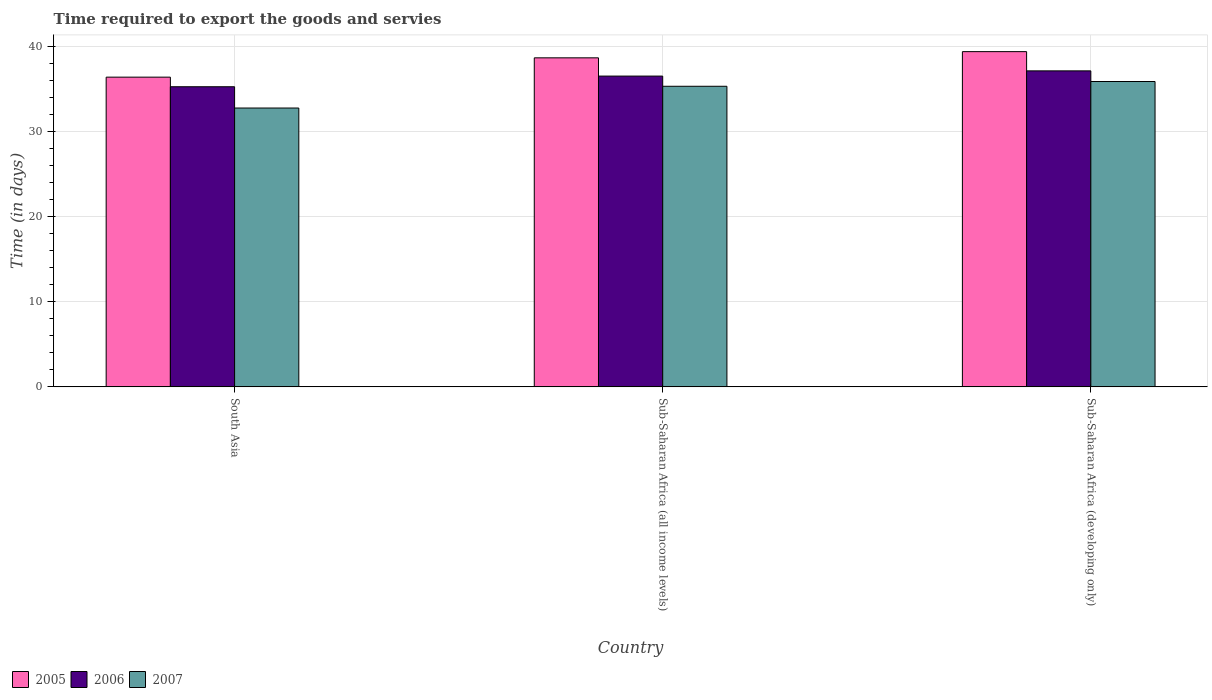How many different coloured bars are there?
Offer a very short reply. 3. How many groups of bars are there?
Your answer should be compact. 3. Are the number of bars per tick equal to the number of legend labels?
Offer a very short reply. Yes. How many bars are there on the 3rd tick from the right?
Offer a very short reply. 3. What is the label of the 3rd group of bars from the left?
Give a very brief answer. Sub-Saharan Africa (developing only). In how many cases, is the number of bars for a given country not equal to the number of legend labels?
Keep it short and to the point. 0. What is the number of days required to export the goods and services in 2005 in Sub-Saharan Africa (all income levels)?
Your response must be concise. 38.64. Across all countries, what is the maximum number of days required to export the goods and services in 2007?
Your answer should be compact. 35.86. Across all countries, what is the minimum number of days required to export the goods and services in 2006?
Your answer should be compact. 35.25. In which country was the number of days required to export the goods and services in 2007 maximum?
Give a very brief answer. Sub-Saharan Africa (developing only). What is the total number of days required to export the goods and services in 2007 in the graph?
Provide a succinct answer. 103.92. What is the difference between the number of days required to export the goods and services in 2007 in South Asia and that in Sub-Saharan Africa (developing only)?
Ensure brevity in your answer.  -3.11. What is the difference between the number of days required to export the goods and services in 2005 in South Asia and the number of days required to export the goods and services in 2007 in Sub-Saharan Africa (developing only)?
Offer a terse response. 0.51. What is the average number of days required to export the goods and services in 2006 per country?
Your response must be concise. 36.29. What is the difference between the number of days required to export the goods and services of/in 2007 and number of days required to export the goods and services of/in 2005 in Sub-Saharan Africa (developing only)?
Provide a short and direct response. -3.51. What is the ratio of the number of days required to export the goods and services in 2007 in South Asia to that in Sub-Saharan Africa (developing only)?
Offer a terse response. 0.91. Is the number of days required to export the goods and services in 2006 in Sub-Saharan Africa (all income levels) less than that in Sub-Saharan Africa (developing only)?
Your response must be concise. Yes. What is the difference between the highest and the second highest number of days required to export the goods and services in 2006?
Provide a short and direct response. -1.25. What is the difference between the highest and the lowest number of days required to export the goods and services in 2005?
Make the answer very short. 3. In how many countries, is the number of days required to export the goods and services in 2005 greater than the average number of days required to export the goods and services in 2005 taken over all countries?
Ensure brevity in your answer.  2. Is the sum of the number of days required to export the goods and services in 2006 in Sub-Saharan Africa (all income levels) and Sub-Saharan Africa (developing only) greater than the maximum number of days required to export the goods and services in 2005 across all countries?
Offer a terse response. Yes. What does the 1st bar from the right in Sub-Saharan Africa (all income levels) represents?
Provide a short and direct response. 2007. Are all the bars in the graph horizontal?
Offer a terse response. No. How many countries are there in the graph?
Provide a succinct answer. 3. What is the difference between two consecutive major ticks on the Y-axis?
Your answer should be compact. 10. Are the values on the major ticks of Y-axis written in scientific E-notation?
Offer a terse response. No. Does the graph contain grids?
Make the answer very short. Yes. Where does the legend appear in the graph?
Give a very brief answer. Bottom left. How are the legend labels stacked?
Offer a very short reply. Horizontal. What is the title of the graph?
Make the answer very short. Time required to export the goods and servies. What is the label or title of the Y-axis?
Offer a very short reply. Time (in days). What is the Time (in days) in 2005 in South Asia?
Give a very brief answer. 36.38. What is the Time (in days) of 2006 in South Asia?
Keep it short and to the point. 35.25. What is the Time (in days) in 2007 in South Asia?
Your response must be concise. 32.75. What is the Time (in days) of 2005 in Sub-Saharan Africa (all income levels)?
Your response must be concise. 38.64. What is the Time (in days) of 2006 in Sub-Saharan Africa (all income levels)?
Keep it short and to the point. 36.5. What is the Time (in days) in 2007 in Sub-Saharan Africa (all income levels)?
Your answer should be compact. 35.3. What is the Time (in days) in 2005 in Sub-Saharan Africa (developing only)?
Your answer should be very brief. 39.37. What is the Time (in days) of 2006 in Sub-Saharan Africa (developing only)?
Your answer should be compact. 37.11. What is the Time (in days) in 2007 in Sub-Saharan Africa (developing only)?
Your response must be concise. 35.86. Across all countries, what is the maximum Time (in days) of 2005?
Your response must be concise. 39.37. Across all countries, what is the maximum Time (in days) in 2006?
Make the answer very short. 37.11. Across all countries, what is the maximum Time (in days) of 2007?
Keep it short and to the point. 35.86. Across all countries, what is the minimum Time (in days) of 2005?
Your answer should be very brief. 36.38. Across all countries, what is the minimum Time (in days) of 2006?
Make the answer very short. 35.25. Across all countries, what is the minimum Time (in days) in 2007?
Your response must be concise. 32.75. What is the total Time (in days) of 2005 in the graph?
Make the answer very short. 114.39. What is the total Time (in days) in 2006 in the graph?
Offer a very short reply. 108.86. What is the total Time (in days) in 2007 in the graph?
Your answer should be compact. 103.92. What is the difference between the Time (in days) of 2005 in South Asia and that in Sub-Saharan Africa (all income levels)?
Offer a very short reply. -2.27. What is the difference between the Time (in days) of 2006 in South Asia and that in Sub-Saharan Africa (all income levels)?
Give a very brief answer. -1.25. What is the difference between the Time (in days) in 2007 in South Asia and that in Sub-Saharan Africa (all income levels)?
Make the answer very short. -2.55. What is the difference between the Time (in days) in 2005 in South Asia and that in Sub-Saharan Africa (developing only)?
Provide a short and direct response. -3. What is the difference between the Time (in days) of 2006 in South Asia and that in Sub-Saharan Africa (developing only)?
Your answer should be very brief. -1.86. What is the difference between the Time (in days) in 2007 in South Asia and that in Sub-Saharan Africa (developing only)?
Your response must be concise. -3.11. What is the difference between the Time (in days) in 2005 in Sub-Saharan Africa (all income levels) and that in Sub-Saharan Africa (developing only)?
Your answer should be compact. -0.73. What is the difference between the Time (in days) in 2006 in Sub-Saharan Africa (all income levels) and that in Sub-Saharan Africa (developing only)?
Your response must be concise. -0.61. What is the difference between the Time (in days) of 2007 in Sub-Saharan Africa (all income levels) and that in Sub-Saharan Africa (developing only)?
Your response must be concise. -0.56. What is the difference between the Time (in days) of 2005 in South Asia and the Time (in days) of 2006 in Sub-Saharan Africa (all income levels)?
Provide a short and direct response. -0.12. What is the difference between the Time (in days) of 2005 in South Asia and the Time (in days) of 2007 in Sub-Saharan Africa (all income levels)?
Ensure brevity in your answer.  1.07. What is the difference between the Time (in days) in 2006 in South Asia and the Time (in days) in 2007 in Sub-Saharan Africa (all income levels)?
Your response must be concise. -0.05. What is the difference between the Time (in days) of 2005 in South Asia and the Time (in days) of 2006 in Sub-Saharan Africa (developing only)?
Provide a succinct answer. -0.74. What is the difference between the Time (in days) of 2005 in South Asia and the Time (in days) of 2007 in Sub-Saharan Africa (developing only)?
Provide a short and direct response. 0.51. What is the difference between the Time (in days) in 2006 in South Asia and the Time (in days) in 2007 in Sub-Saharan Africa (developing only)?
Provide a short and direct response. -0.61. What is the difference between the Time (in days) of 2005 in Sub-Saharan Africa (all income levels) and the Time (in days) of 2006 in Sub-Saharan Africa (developing only)?
Your answer should be very brief. 1.53. What is the difference between the Time (in days) in 2005 in Sub-Saharan Africa (all income levels) and the Time (in days) in 2007 in Sub-Saharan Africa (developing only)?
Give a very brief answer. 2.78. What is the difference between the Time (in days) of 2006 in Sub-Saharan Africa (all income levels) and the Time (in days) of 2007 in Sub-Saharan Africa (developing only)?
Your answer should be very brief. 0.64. What is the average Time (in days) in 2005 per country?
Provide a succinct answer. 38.13. What is the average Time (in days) in 2006 per country?
Keep it short and to the point. 36.29. What is the average Time (in days) of 2007 per country?
Your response must be concise. 34.64. What is the difference between the Time (in days) in 2005 and Time (in days) in 2006 in South Asia?
Your response must be concise. 1.12. What is the difference between the Time (in days) in 2005 and Time (in days) in 2007 in South Asia?
Your answer should be very brief. 3.62. What is the difference between the Time (in days) of 2006 and Time (in days) of 2007 in South Asia?
Make the answer very short. 2.5. What is the difference between the Time (in days) of 2005 and Time (in days) of 2006 in Sub-Saharan Africa (all income levels)?
Provide a short and direct response. 2.14. What is the difference between the Time (in days) in 2005 and Time (in days) in 2007 in Sub-Saharan Africa (all income levels)?
Provide a succinct answer. 3.34. What is the difference between the Time (in days) in 2006 and Time (in days) in 2007 in Sub-Saharan Africa (all income levels)?
Give a very brief answer. 1.2. What is the difference between the Time (in days) of 2005 and Time (in days) of 2006 in Sub-Saharan Africa (developing only)?
Provide a succinct answer. 2.26. What is the difference between the Time (in days) of 2005 and Time (in days) of 2007 in Sub-Saharan Africa (developing only)?
Provide a succinct answer. 3.51. What is the difference between the Time (in days) in 2006 and Time (in days) in 2007 in Sub-Saharan Africa (developing only)?
Make the answer very short. 1.25. What is the ratio of the Time (in days) in 2005 in South Asia to that in Sub-Saharan Africa (all income levels)?
Your answer should be compact. 0.94. What is the ratio of the Time (in days) of 2006 in South Asia to that in Sub-Saharan Africa (all income levels)?
Offer a terse response. 0.97. What is the ratio of the Time (in days) in 2007 in South Asia to that in Sub-Saharan Africa (all income levels)?
Offer a very short reply. 0.93. What is the ratio of the Time (in days) in 2005 in South Asia to that in Sub-Saharan Africa (developing only)?
Offer a very short reply. 0.92. What is the ratio of the Time (in days) in 2006 in South Asia to that in Sub-Saharan Africa (developing only)?
Give a very brief answer. 0.95. What is the ratio of the Time (in days) of 2007 in South Asia to that in Sub-Saharan Africa (developing only)?
Offer a terse response. 0.91. What is the ratio of the Time (in days) of 2005 in Sub-Saharan Africa (all income levels) to that in Sub-Saharan Africa (developing only)?
Provide a short and direct response. 0.98. What is the ratio of the Time (in days) in 2006 in Sub-Saharan Africa (all income levels) to that in Sub-Saharan Africa (developing only)?
Your answer should be compact. 0.98. What is the ratio of the Time (in days) in 2007 in Sub-Saharan Africa (all income levels) to that in Sub-Saharan Africa (developing only)?
Ensure brevity in your answer.  0.98. What is the difference between the highest and the second highest Time (in days) of 2005?
Offer a terse response. 0.73. What is the difference between the highest and the second highest Time (in days) in 2006?
Provide a short and direct response. 0.61. What is the difference between the highest and the second highest Time (in days) in 2007?
Give a very brief answer. 0.56. What is the difference between the highest and the lowest Time (in days) in 2005?
Provide a short and direct response. 3. What is the difference between the highest and the lowest Time (in days) in 2006?
Offer a terse response. 1.86. What is the difference between the highest and the lowest Time (in days) of 2007?
Provide a short and direct response. 3.11. 